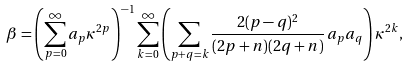Convert formula to latex. <formula><loc_0><loc_0><loc_500><loc_500>\beta = \left ( \sum _ { p = 0 } ^ { \infty } a _ { p } \kappa ^ { 2 p } \right ) ^ { - 1 } \sum _ { k = 0 } ^ { \infty } \left ( \sum _ { p + q = k } \frac { 2 ( p - q ) ^ { 2 } } { ( 2 p + n ) ( 2 q + n ) } \, a _ { p } a _ { q } \right ) \kappa ^ { 2 k } ,</formula> 